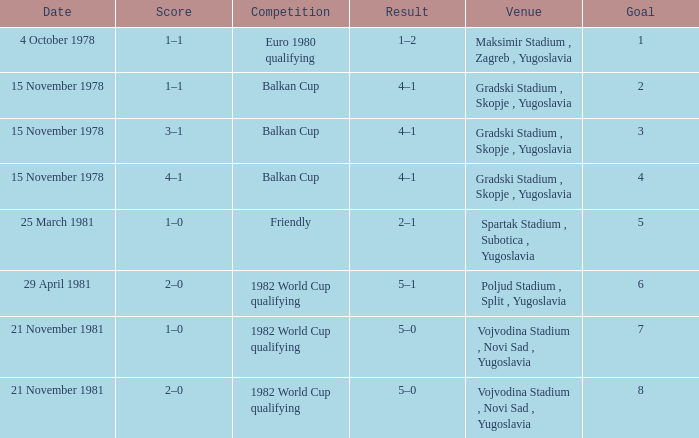What is the Result for Goal 3? 4–1. 